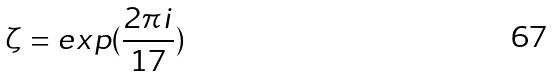<formula> <loc_0><loc_0><loc_500><loc_500>\zeta = e x p ( \frac { 2 \pi i } { 1 7 } )</formula> 